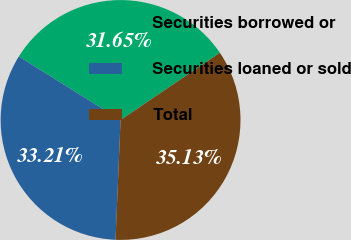Convert chart. <chart><loc_0><loc_0><loc_500><loc_500><pie_chart><fcel>Securities borrowed or<fcel>Securities loaned or sold<fcel>Total<nl><fcel>31.65%<fcel>33.21%<fcel>35.13%<nl></chart> 